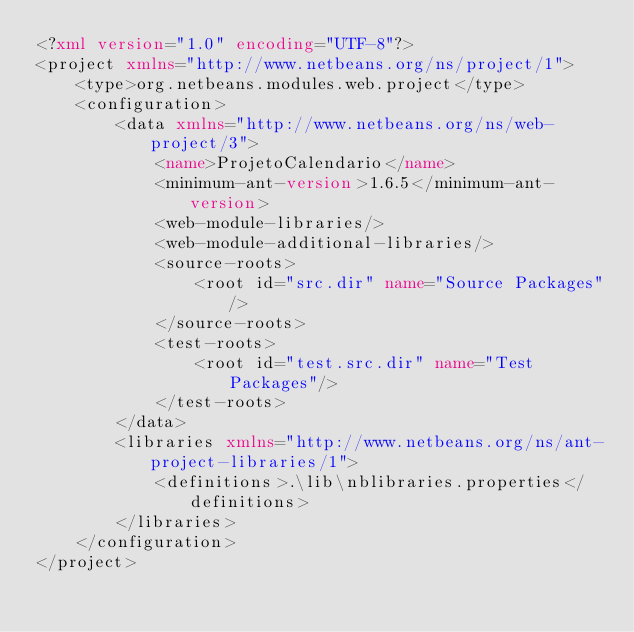<code> <loc_0><loc_0><loc_500><loc_500><_XML_><?xml version="1.0" encoding="UTF-8"?>
<project xmlns="http://www.netbeans.org/ns/project/1">
    <type>org.netbeans.modules.web.project</type>
    <configuration>
        <data xmlns="http://www.netbeans.org/ns/web-project/3">
            <name>ProjetoCalendario</name>
            <minimum-ant-version>1.6.5</minimum-ant-version>
            <web-module-libraries/>
            <web-module-additional-libraries/>
            <source-roots>
                <root id="src.dir" name="Source Packages"/>
            </source-roots>
            <test-roots>
                <root id="test.src.dir" name="Test Packages"/>
            </test-roots>
        </data>
        <libraries xmlns="http://www.netbeans.org/ns/ant-project-libraries/1">
            <definitions>.\lib\nblibraries.properties</definitions>
        </libraries>
    </configuration>
</project>
</code> 